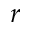Convert formula to latex. <formula><loc_0><loc_0><loc_500><loc_500>r</formula> 